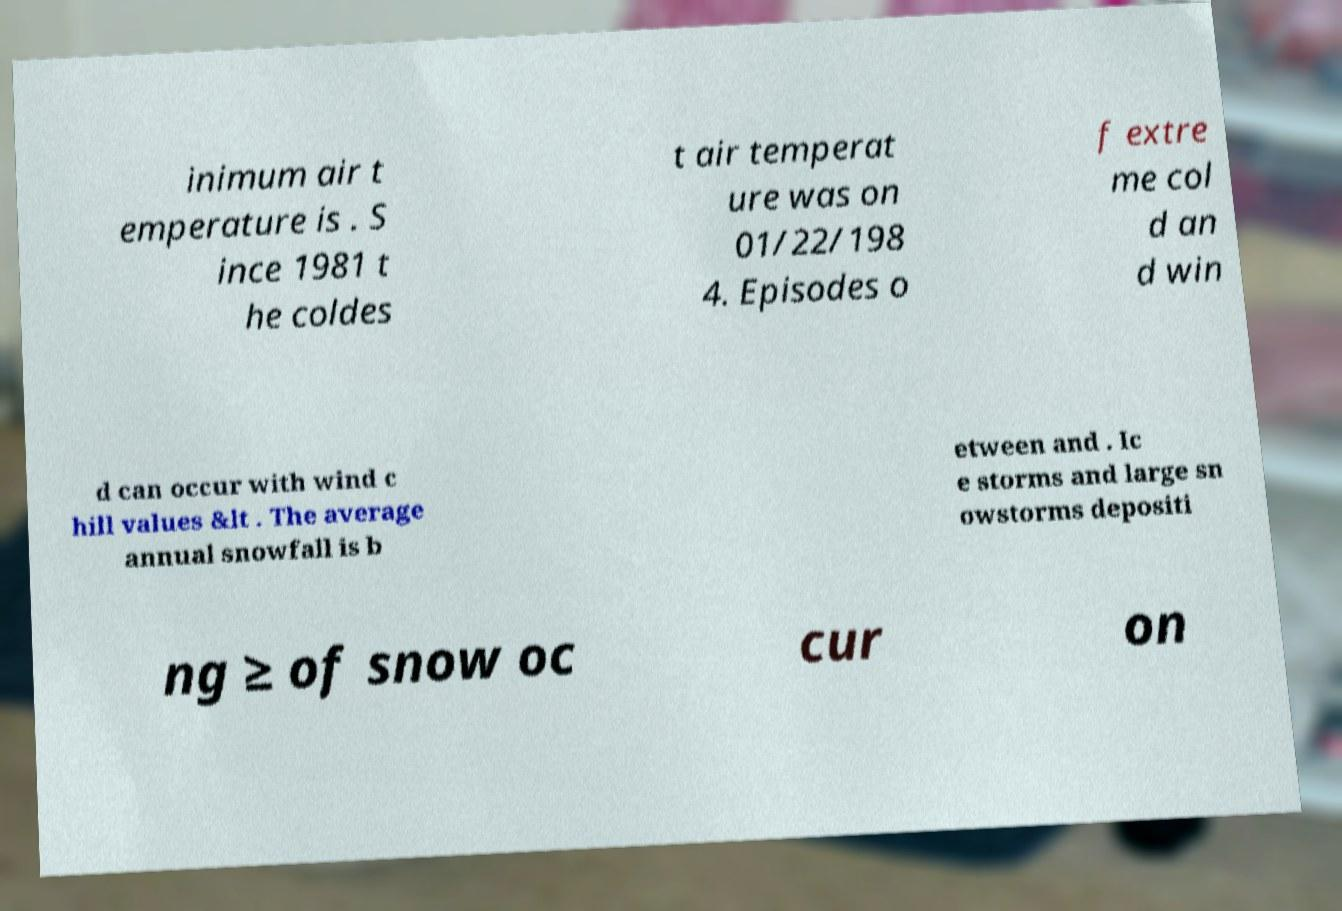Can you read and provide the text displayed in the image?This photo seems to have some interesting text. Can you extract and type it out for me? inimum air t emperature is . S ince 1981 t he coldes t air temperat ure was on 01/22/198 4. Episodes o f extre me col d an d win d can occur with wind c hill values &lt . The average annual snowfall is b etween and . Ic e storms and large sn owstorms depositi ng ≥ of snow oc cur on 